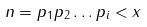Convert formula to latex. <formula><loc_0><loc_0><loc_500><loc_500>n = p _ { 1 } p _ { 2 } \dots p _ { i } < x</formula> 